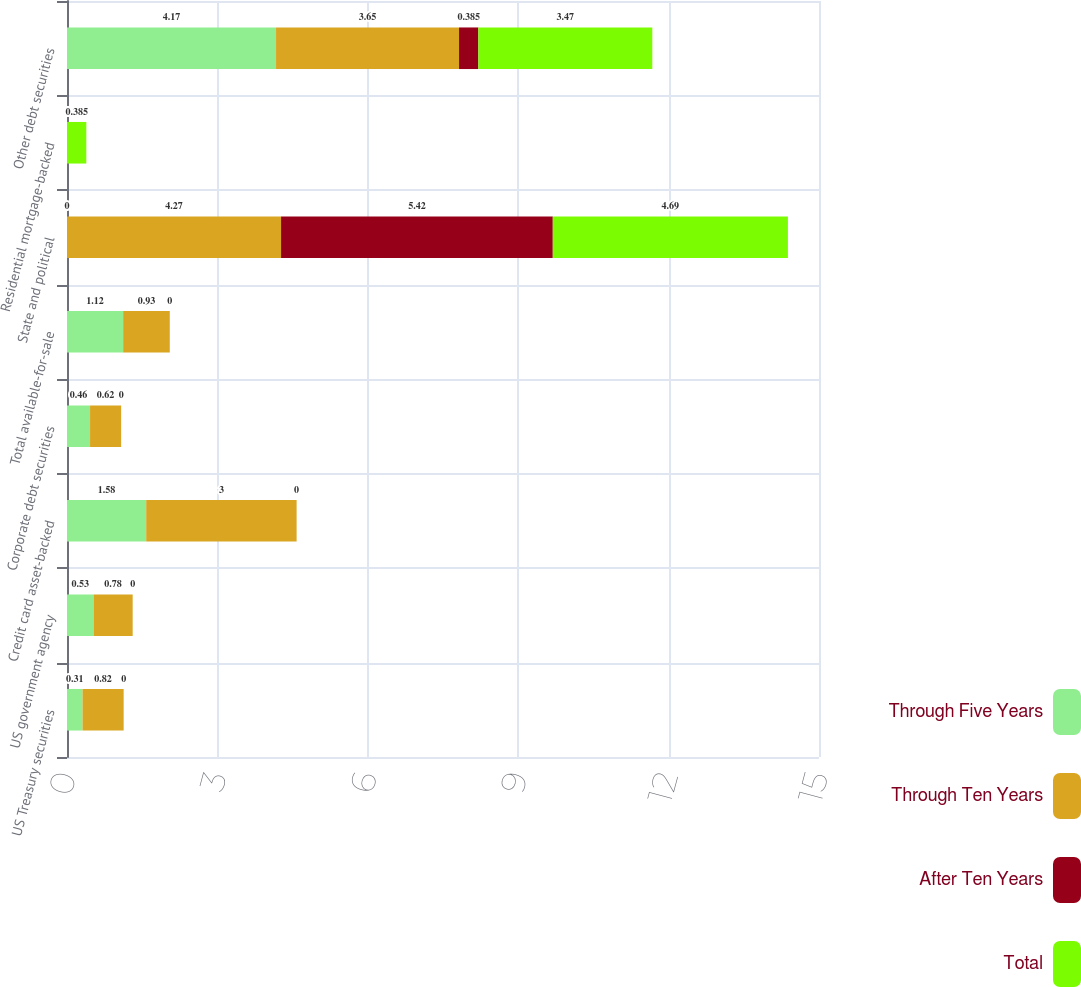<chart> <loc_0><loc_0><loc_500><loc_500><stacked_bar_chart><ecel><fcel>US Treasury securities<fcel>US government agency<fcel>Credit card asset-backed<fcel>Corporate debt securities<fcel>Total available-for-sale<fcel>State and political<fcel>Residential mortgage-backed<fcel>Other debt securities<nl><fcel>Through Five Years<fcel>0.31<fcel>0.53<fcel>1.58<fcel>0.46<fcel>1.12<fcel>0<fcel>0<fcel>4.17<nl><fcel>Through Ten Years<fcel>0.82<fcel>0.78<fcel>3<fcel>0.62<fcel>0.93<fcel>4.27<fcel>0<fcel>3.65<nl><fcel>After Ten Years<fcel>0<fcel>0<fcel>0<fcel>0<fcel>0<fcel>5.42<fcel>0<fcel>0.385<nl><fcel>Total<fcel>0<fcel>0<fcel>0<fcel>0<fcel>0<fcel>4.69<fcel>0.385<fcel>3.47<nl></chart> 